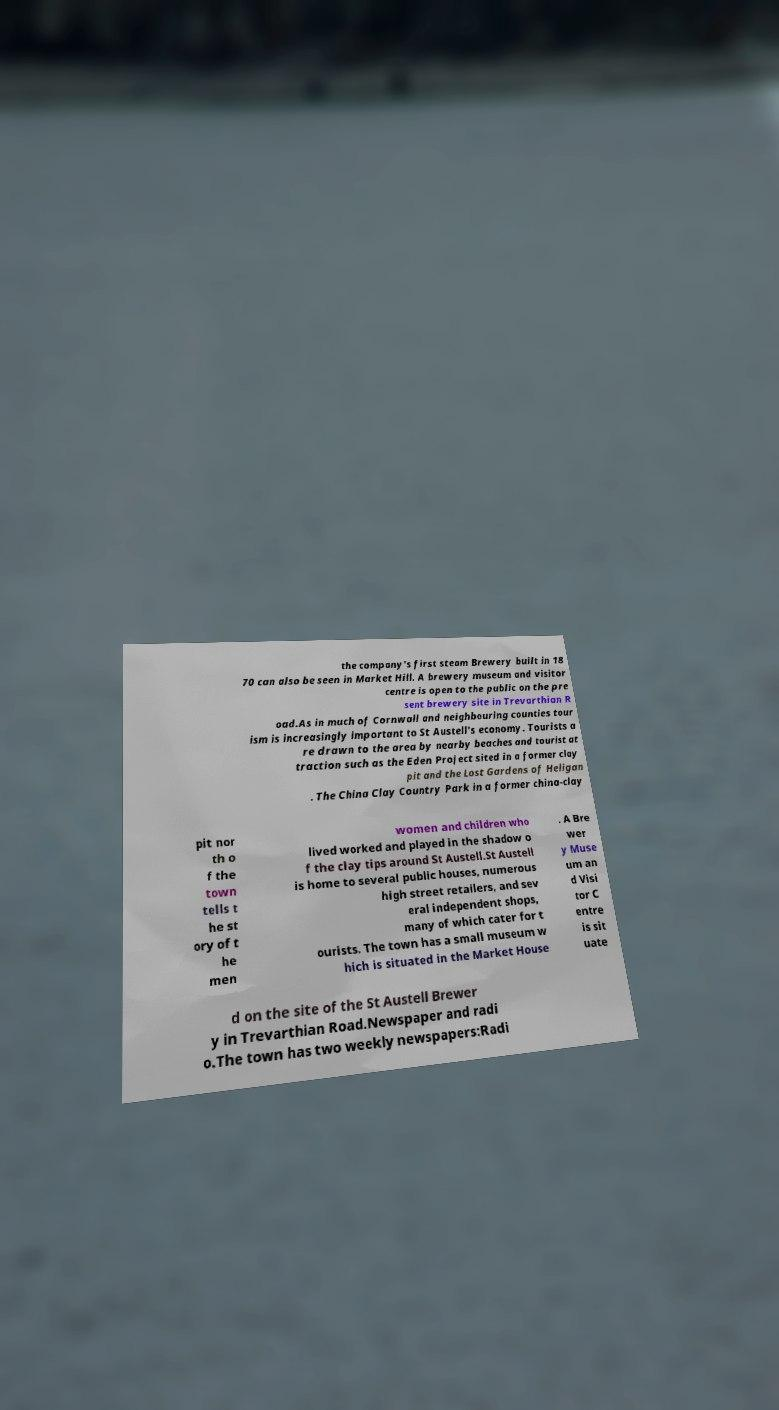Can you accurately transcribe the text from the provided image for me? the company's first steam Brewery built in 18 70 can also be seen in Market Hill. A brewery museum and visitor centre is open to the public on the pre sent brewery site in Trevarthian R oad.As in much of Cornwall and neighbouring counties tour ism is increasingly important to St Austell's economy. Tourists a re drawn to the area by nearby beaches and tourist at traction such as the Eden Project sited in a former clay pit and the Lost Gardens of Heligan . The China Clay Country Park in a former china-clay pit nor th o f the town tells t he st ory of t he men women and children who lived worked and played in the shadow o f the clay tips around St Austell.St Austell is home to several public houses, numerous high street retailers, and sev eral independent shops, many of which cater for t ourists. The town has a small museum w hich is situated in the Market House . A Bre wer y Muse um an d Visi tor C entre is sit uate d on the site of the St Austell Brewer y in Trevarthian Road.Newspaper and radi o.The town has two weekly newspapers:Radi 